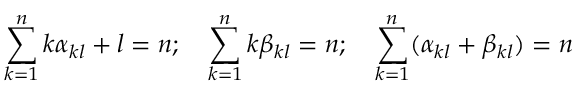<formula> <loc_0><loc_0><loc_500><loc_500>\sum _ { k = 1 } ^ { n } k \alpha _ { k l } + l = n ; \quad \sum _ { k = 1 } ^ { n } k \beta _ { k l } = n ; \quad \sum _ { k = 1 } ^ { n } ( \alpha _ { k l } + \beta _ { k l } ) = n</formula> 